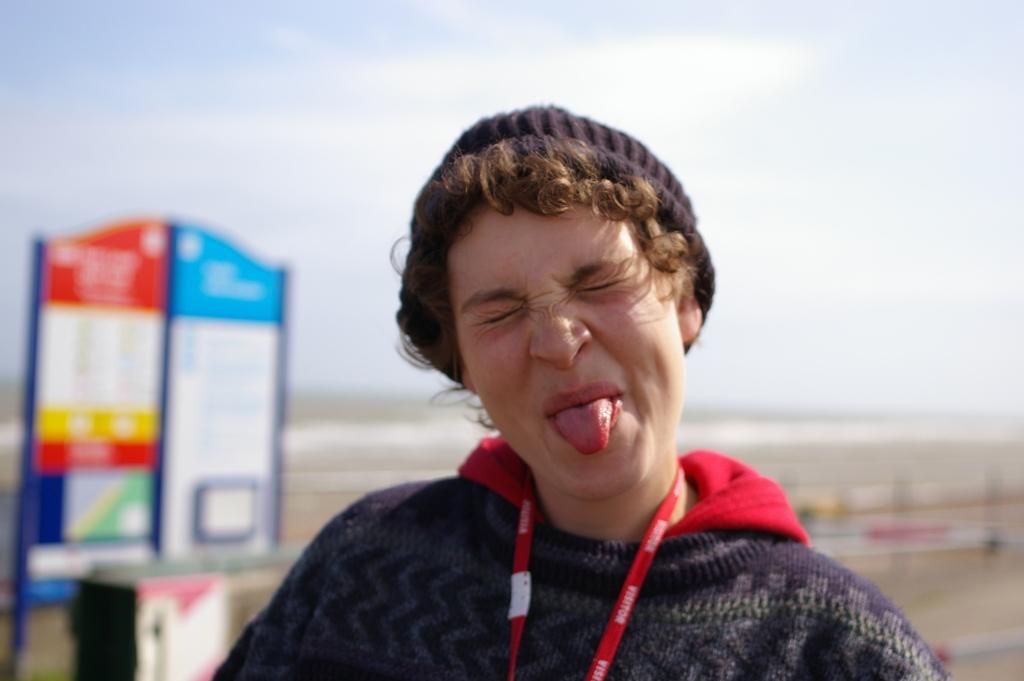Could you give a brief overview of what you see in this image? In this I can see a woman is showing her tongue, she wore sweater, cap. On the left side it looks like a board, at the top it is the sky. 